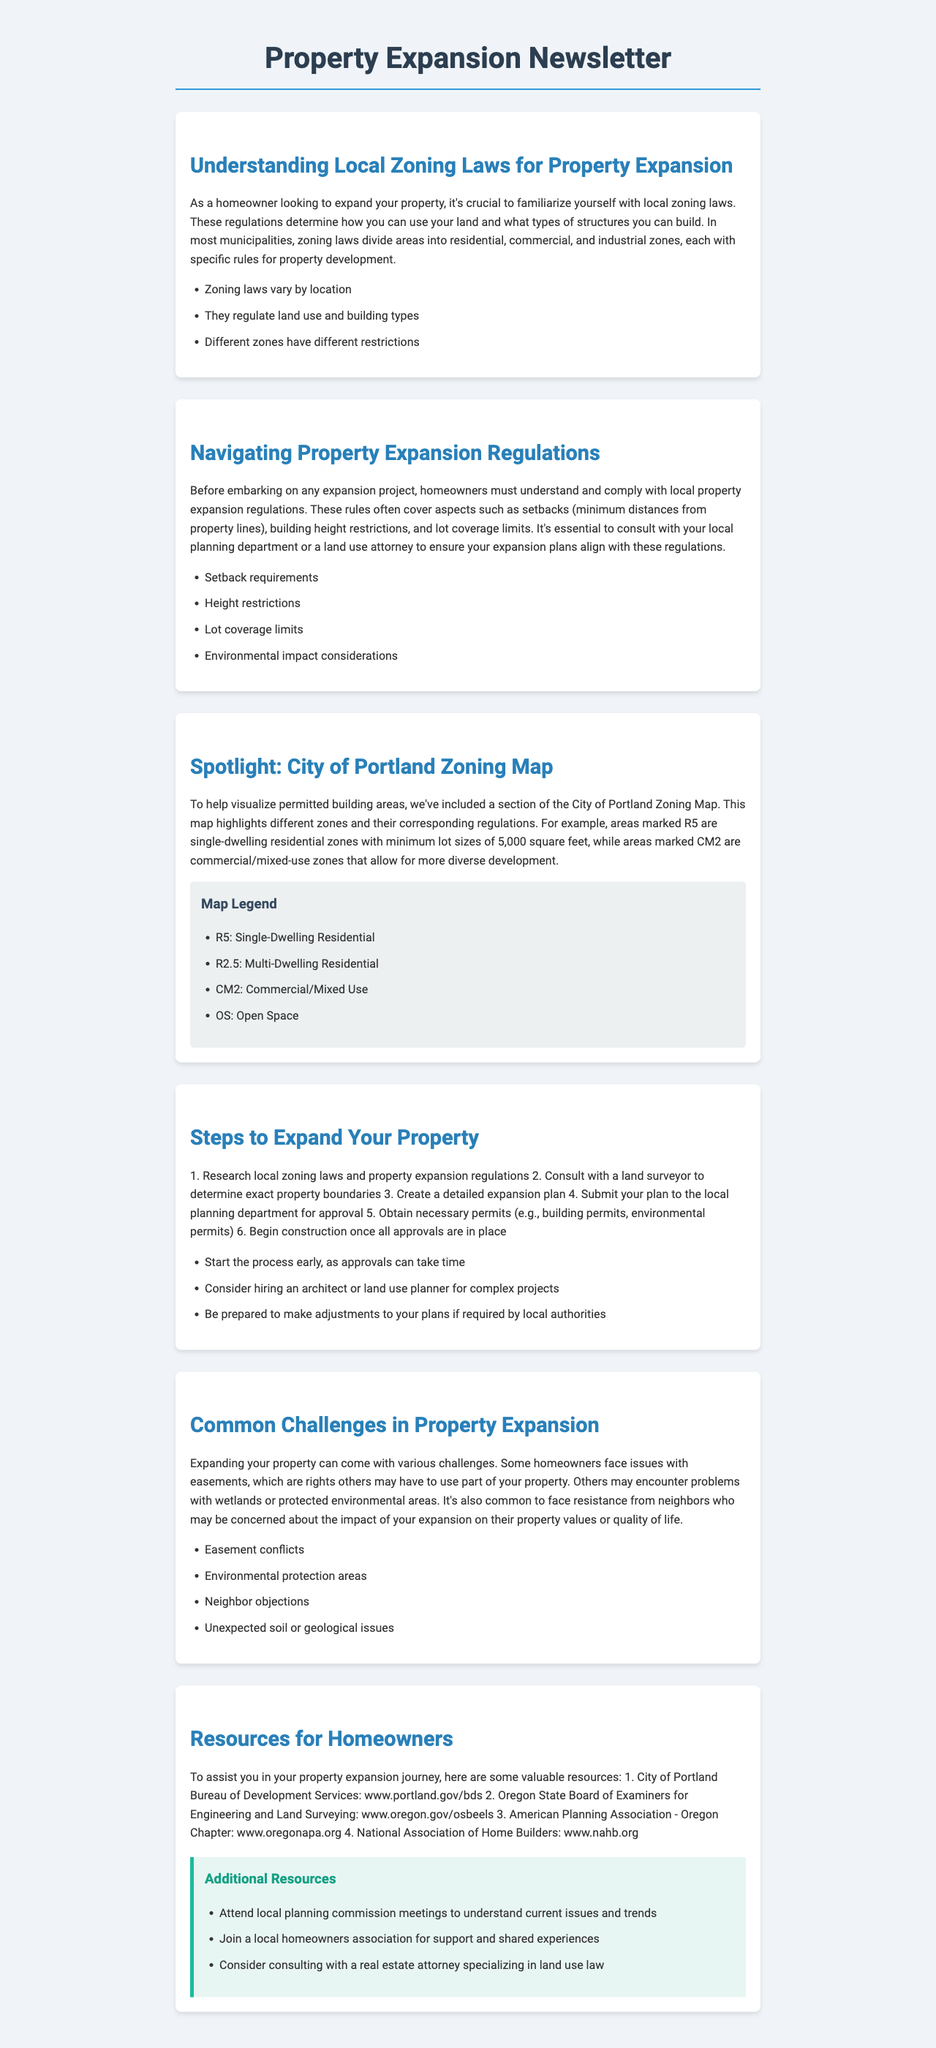What are the types of zones mentioned in the document? The document discusses various zoning types, specifically residential, commercial, and industrial zones.
Answer: residential, commercial, industrial What are the height restrictions? Height restrictions are one of the important regulations mentioned for property expansion, referring to the allowable maximum building height in specific zones.
Answer: Height restrictions What does R5 represent on the zoning map? On the zoning map, R5 represents single-dwelling residential zones with minimum lot sizes of 5,000 square feet.
Answer: Single-Dwelling Residential What is the minimum lot size for R2.5 zones? The document does not specify the minimum lot size for R2.5, but it falls under multi-dwelling residential zones.
Answer: Not specified Which department should homeowners consult for approval? Homeowners are advised to consult the local planning department to ensure their expansion plans comply with regulations.
Answer: Local planning department What is the first step in the property expansion process? The first step to expand your property is to research local zoning laws and property expansion regulations.
Answer: Research local zoning laws What challenges might homeowners face during expansion? The document lists various challenges, including easement conflicts, environmental protection areas, and neighbor objections.
Answer: Easement conflicts, environmental protection areas, neighbor objections Where can homeowners find additional resources? The document provides links to local agencies and associations as valuable resources for homeowners.
Answer: City of Portland Bureau of Development Services, Oregon State Board of Examiners for Engineering and Land Surveying, American Planning Association - Oregon Chapter, National Association of Home Builders 